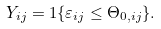<formula> <loc_0><loc_0><loc_500><loc_500>Y _ { i j } = 1 \{ \varepsilon _ { i j } \leq \Theta _ { 0 , i j } \} .</formula> 